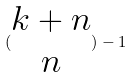<formula> <loc_0><loc_0><loc_500><loc_500>( \begin{matrix} k + n \\ n \end{matrix} ) - 1</formula> 